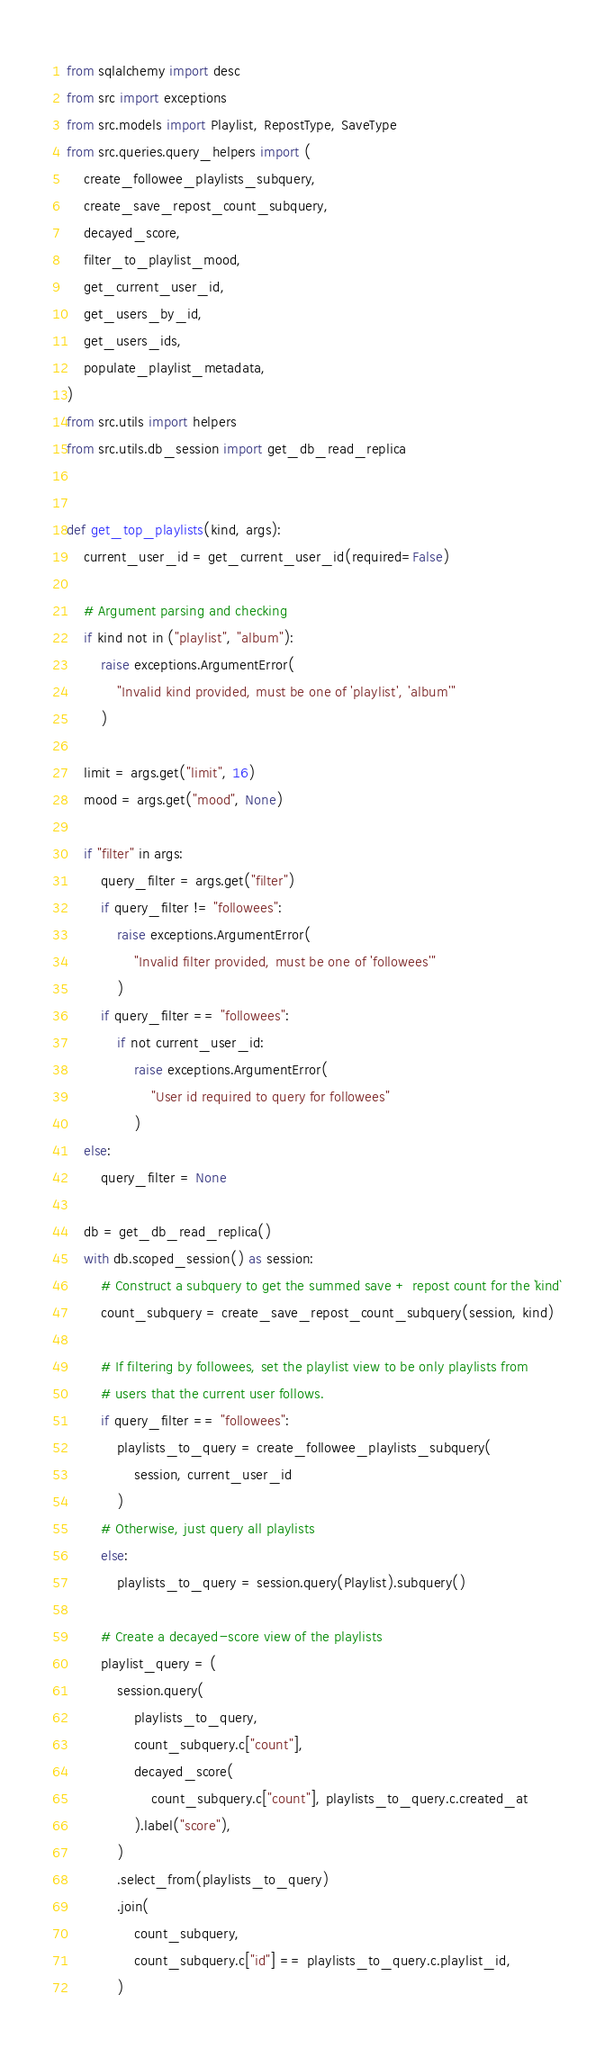<code> <loc_0><loc_0><loc_500><loc_500><_Python_>from sqlalchemy import desc
from src import exceptions
from src.models import Playlist, RepostType, SaveType
from src.queries.query_helpers import (
    create_followee_playlists_subquery,
    create_save_repost_count_subquery,
    decayed_score,
    filter_to_playlist_mood,
    get_current_user_id,
    get_users_by_id,
    get_users_ids,
    populate_playlist_metadata,
)
from src.utils import helpers
from src.utils.db_session import get_db_read_replica


def get_top_playlists(kind, args):
    current_user_id = get_current_user_id(required=False)

    # Argument parsing and checking
    if kind not in ("playlist", "album"):
        raise exceptions.ArgumentError(
            "Invalid kind provided, must be one of 'playlist', 'album'"
        )

    limit = args.get("limit", 16)
    mood = args.get("mood", None)

    if "filter" in args:
        query_filter = args.get("filter")
        if query_filter != "followees":
            raise exceptions.ArgumentError(
                "Invalid filter provided, must be one of 'followees'"
            )
        if query_filter == "followees":
            if not current_user_id:
                raise exceptions.ArgumentError(
                    "User id required to query for followees"
                )
    else:
        query_filter = None

    db = get_db_read_replica()
    with db.scoped_session() as session:
        # Construct a subquery to get the summed save + repost count for the `kind`
        count_subquery = create_save_repost_count_subquery(session, kind)

        # If filtering by followees, set the playlist view to be only playlists from
        # users that the current user follows.
        if query_filter == "followees":
            playlists_to_query = create_followee_playlists_subquery(
                session, current_user_id
            )
        # Otherwise, just query all playlists
        else:
            playlists_to_query = session.query(Playlist).subquery()

        # Create a decayed-score view of the playlists
        playlist_query = (
            session.query(
                playlists_to_query,
                count_subquery.c["count"],
                decayed_score(
                    count_subquery.c["count"], playlists_to_query.c.created_at
                ).label("score"),
            )
            .select_from(playlists_to_query)
            .join(
                count_subquery,
                count_subquery.c["id"] == playlists_to_query.c.playlist_id,
            )</code> 